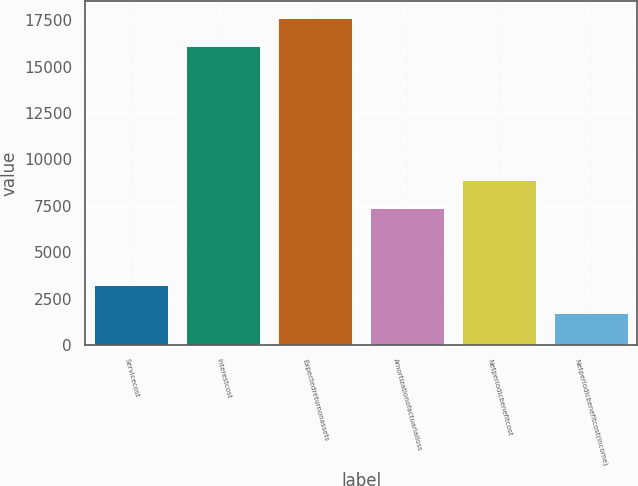Convert chart to OTSL. <chart><loc_0><loc_0><loc_500><loc_500><bar_chart><fcel>Servicecost<fcel>Interestcost<fcel>Expectedreturnonassets<fcel>Amortizationofactuarialloss<fcel>Netperiodicbenefitcost<fcel>Netperiodicbenefitcost(income)<nl><fcel>3237.6<fcel>16106<fcel>17636.6<fcel>7361<fcel>8891.6<fcel>1707<nl></chart> 